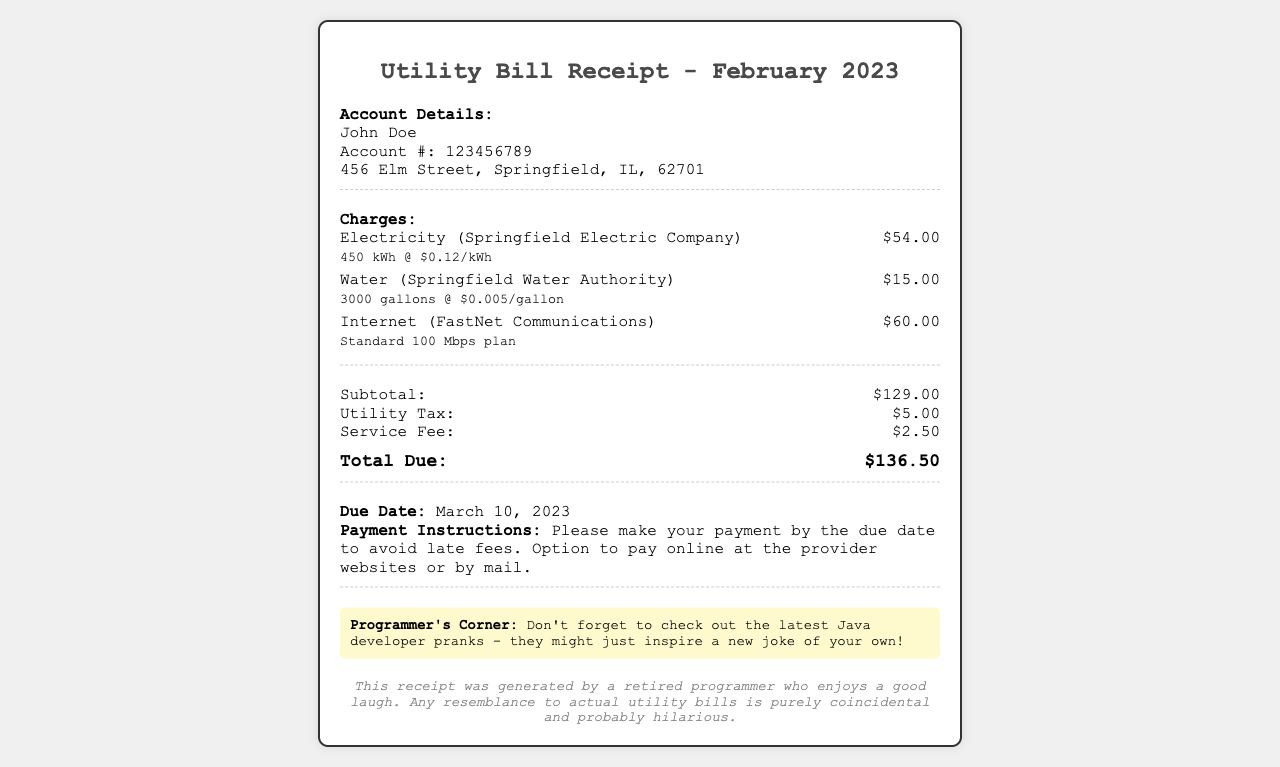what is the total due? The total due is the sum of the subtotal, utility tax, and service fee, which is $129.00 + $5.00 + $2.50 = $136.50.
Answer: $136.50 who is the account holder? The account holder is the individual or entity to whom the utility services are billed, in this case, John Doe.
Answer: John Doe when is the due date? The due date is specified in the document and indicates when the payment must be made, which is March 10, 2023.
Answer: March 10, 2023 how much is the electricity charge? The electricity charge is provided as a specific line item in the bill, which amounts to $54.00.
Answer: $54.00 what is the service fee? The service fee is a cost associated with the utility bill, listed as $2.50 in the document.
Answer: $2.50 what is the total amount of water used? The total amount of water used is mentioned along with its charge, which is 3000 gallons.
Answer: 3000 gallons how much is the utility tax? The utility tax is included in the breakdown of charges, specifically noted as $5.00.
Answer: $5.00 which internet plan is mentioned? The document indicates the type of internet plan provided, stating it is the Standard 100 Mbps plan.
Answer: Standard 100 Mbps plan what is the subtotal before additional charges? The subtotal is the total of all charges before any additional fees or taxes, which is $129.00.
Answer: $129.00 